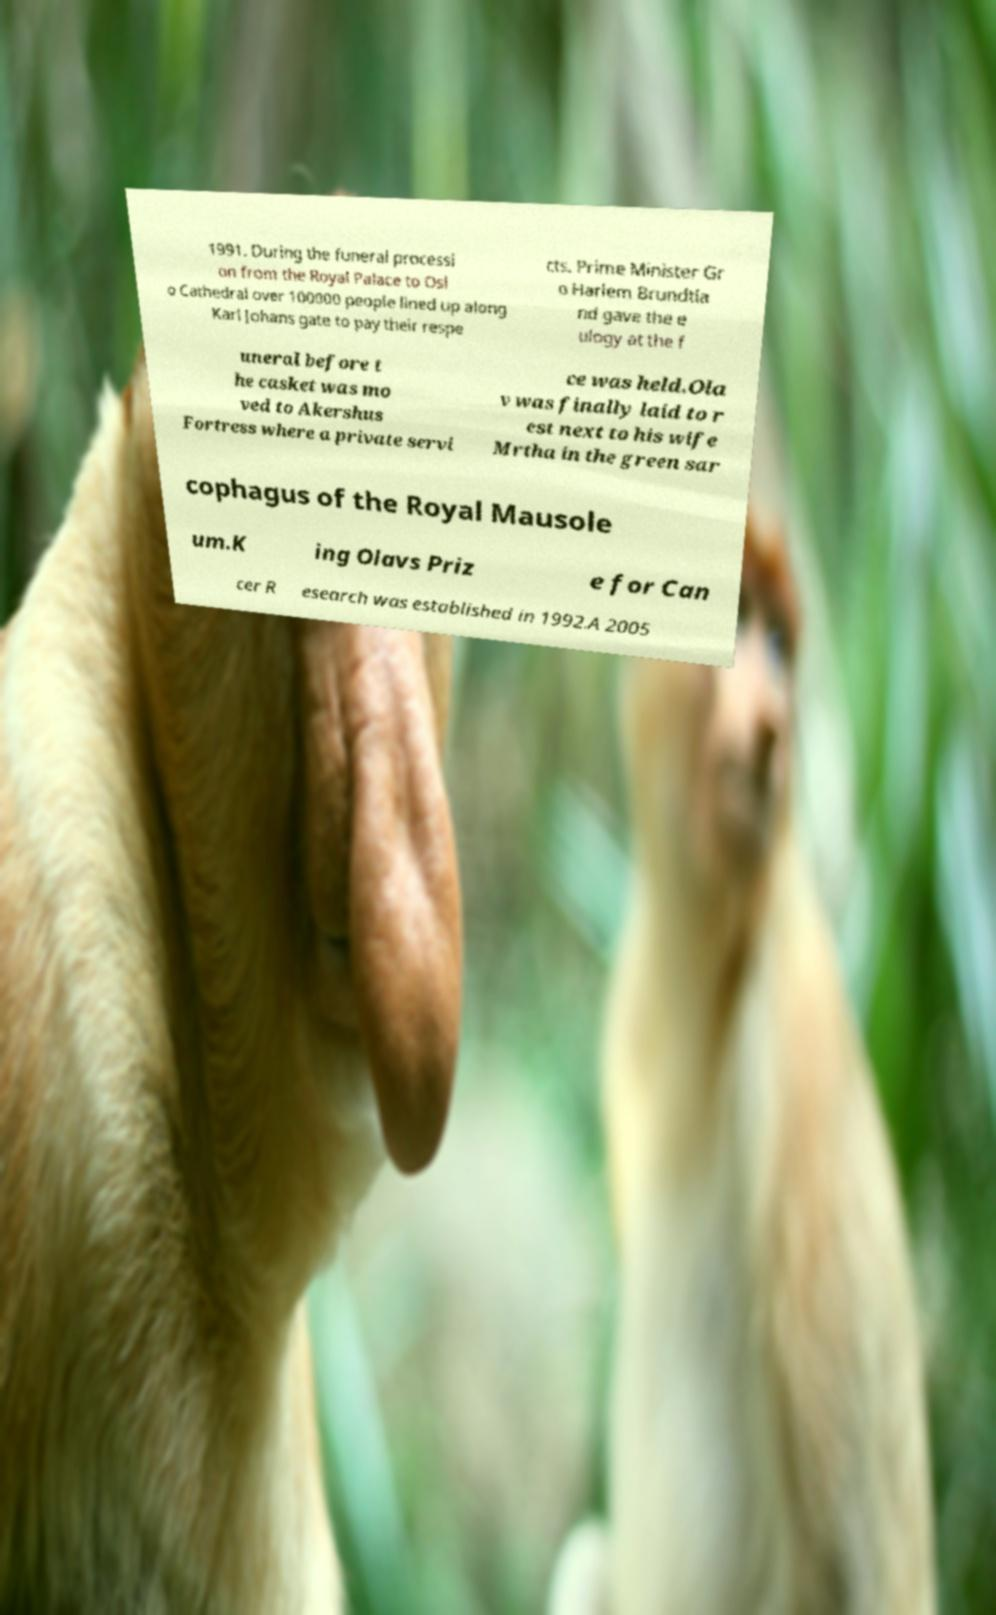Please read and relay the text visible in this image. What does it say? 1991. During the funeral processi on from the Royal Palace to Osl o Cathedral over 100000 people lined up along Karl Johans gate to pay their respe cts. Prime Minister Gr o Harlem Brundtla nd gave the e ulogy at the f uneral before t he casket was mo ved to Akershus Fortress where a private servi ce was held.Ola v was finally laid to r est next to his wife Mrtha in the green sar cophagus of the Royal Mausole um.K ing Olavs Priz e for Can cer R esearch was established in 1992.A 2005 